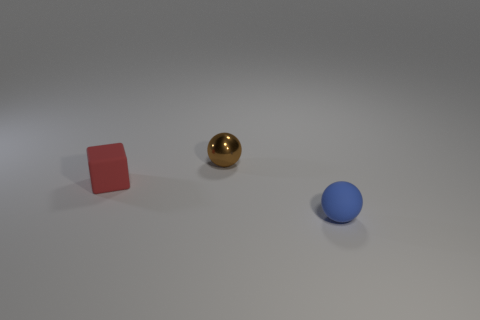How many things are either objects that are behind the red thing or large purple spheres?
Provide a succinct answer. 1. What material is the object that is in front of the thing that is to the left of the metal thing made of?
Your answer should be very brief. Rubber. Is the number of red matte objects that are in front of the blue thing the same as the number of blue things that are in front of the brown metal sphere?
Your answer should be very brief. No. What number of objects are small matte things to the right of the brown thing or things that are behind the blue ball?
Provide a short and direct response. 3. There is a object that is both in front of the metallic ball and to the left of the small blue ball; what material is it?
Offer a terse response. Rubber. Is the number of blue matte objects greater than the number of rubber objects?
Your answer should be very brief. No. Does the tiny sphere that is in front of the small brown sphere have the same material as the tiny red block?
Your answer should be compact. Yes. Are there fewer tiny brown things than small purple shiny things?
Your response must be concise. No. Is there a sphere that is in front of the tiny ball that is to the left of the ball that is in front of the cube?
Keep it short and to the point. Yes. There is a brown metal object that is left of the blue rubber ball; does it have the same shape as the tiny blue thing?
Ensure brevity in your answer.  Yes. 